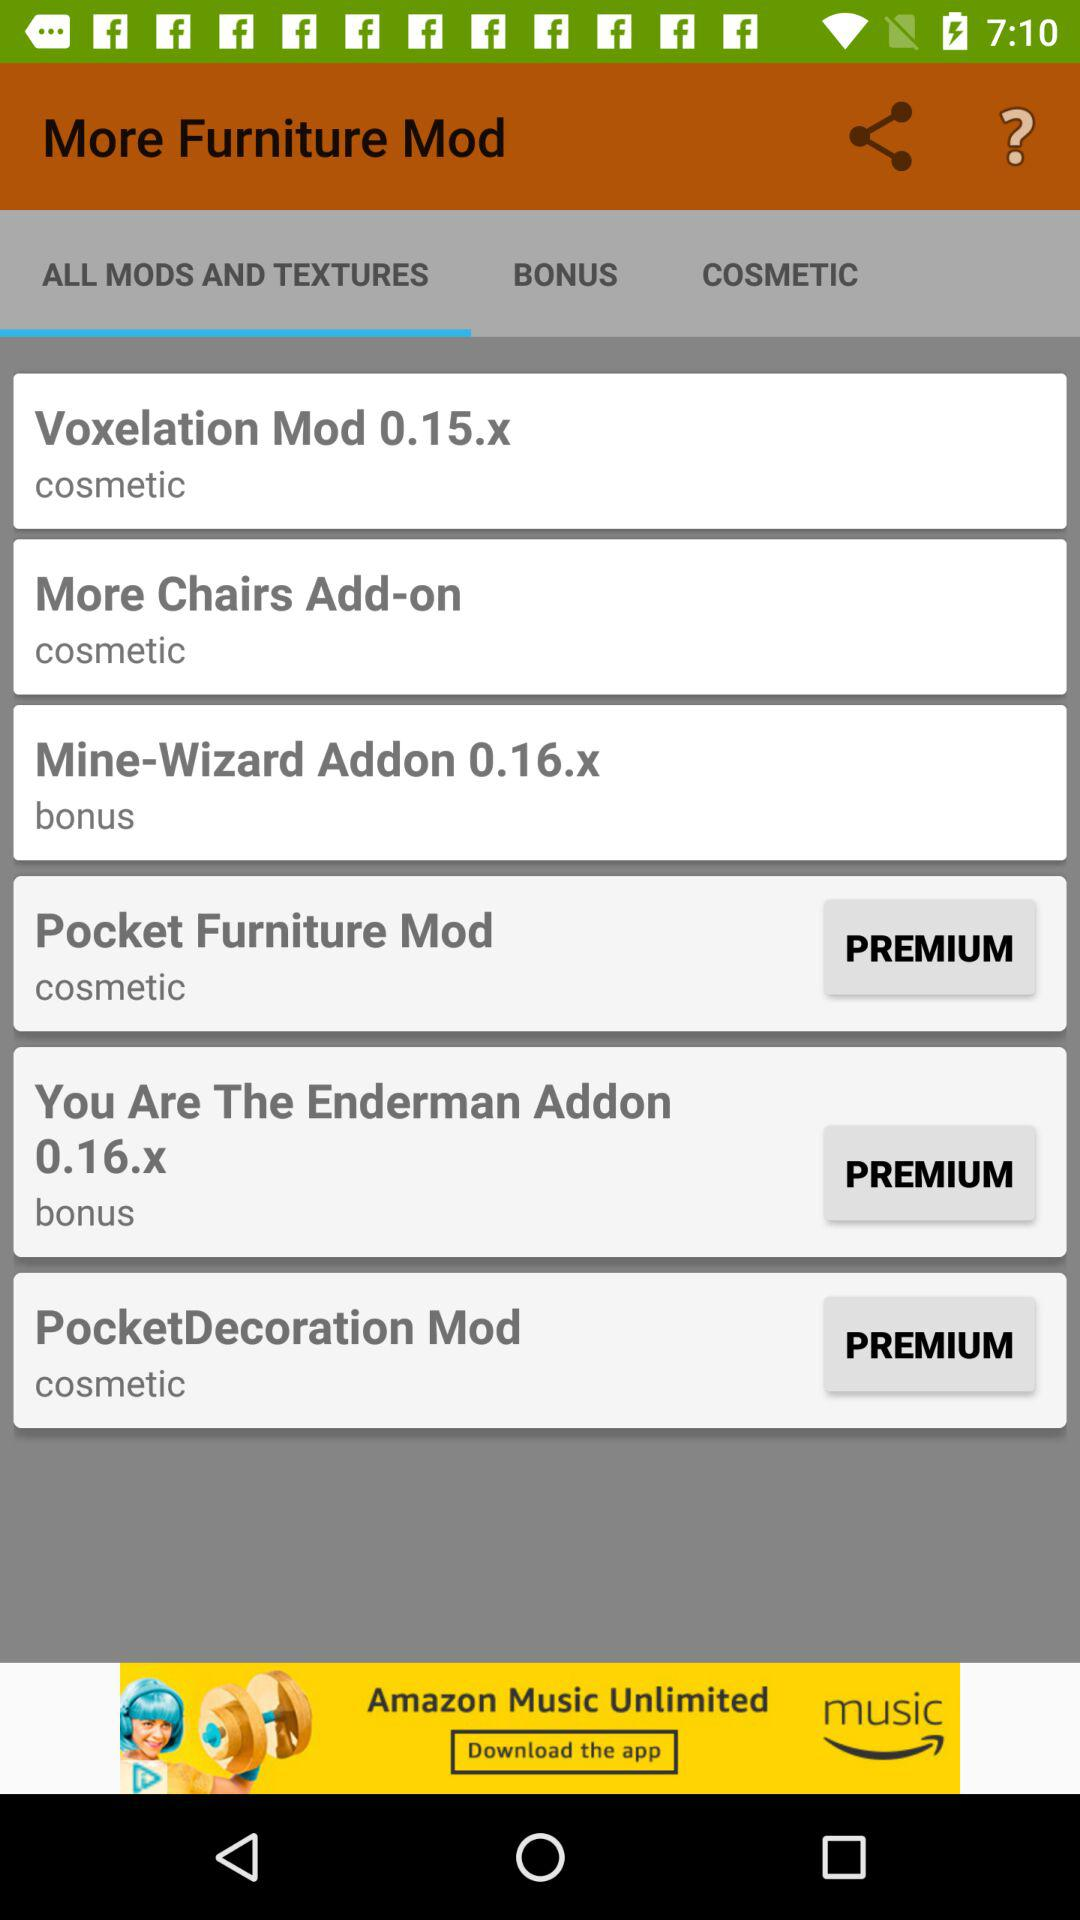Which tab is selected? The selected tab is "ALL MODS AND TEXTURES". 